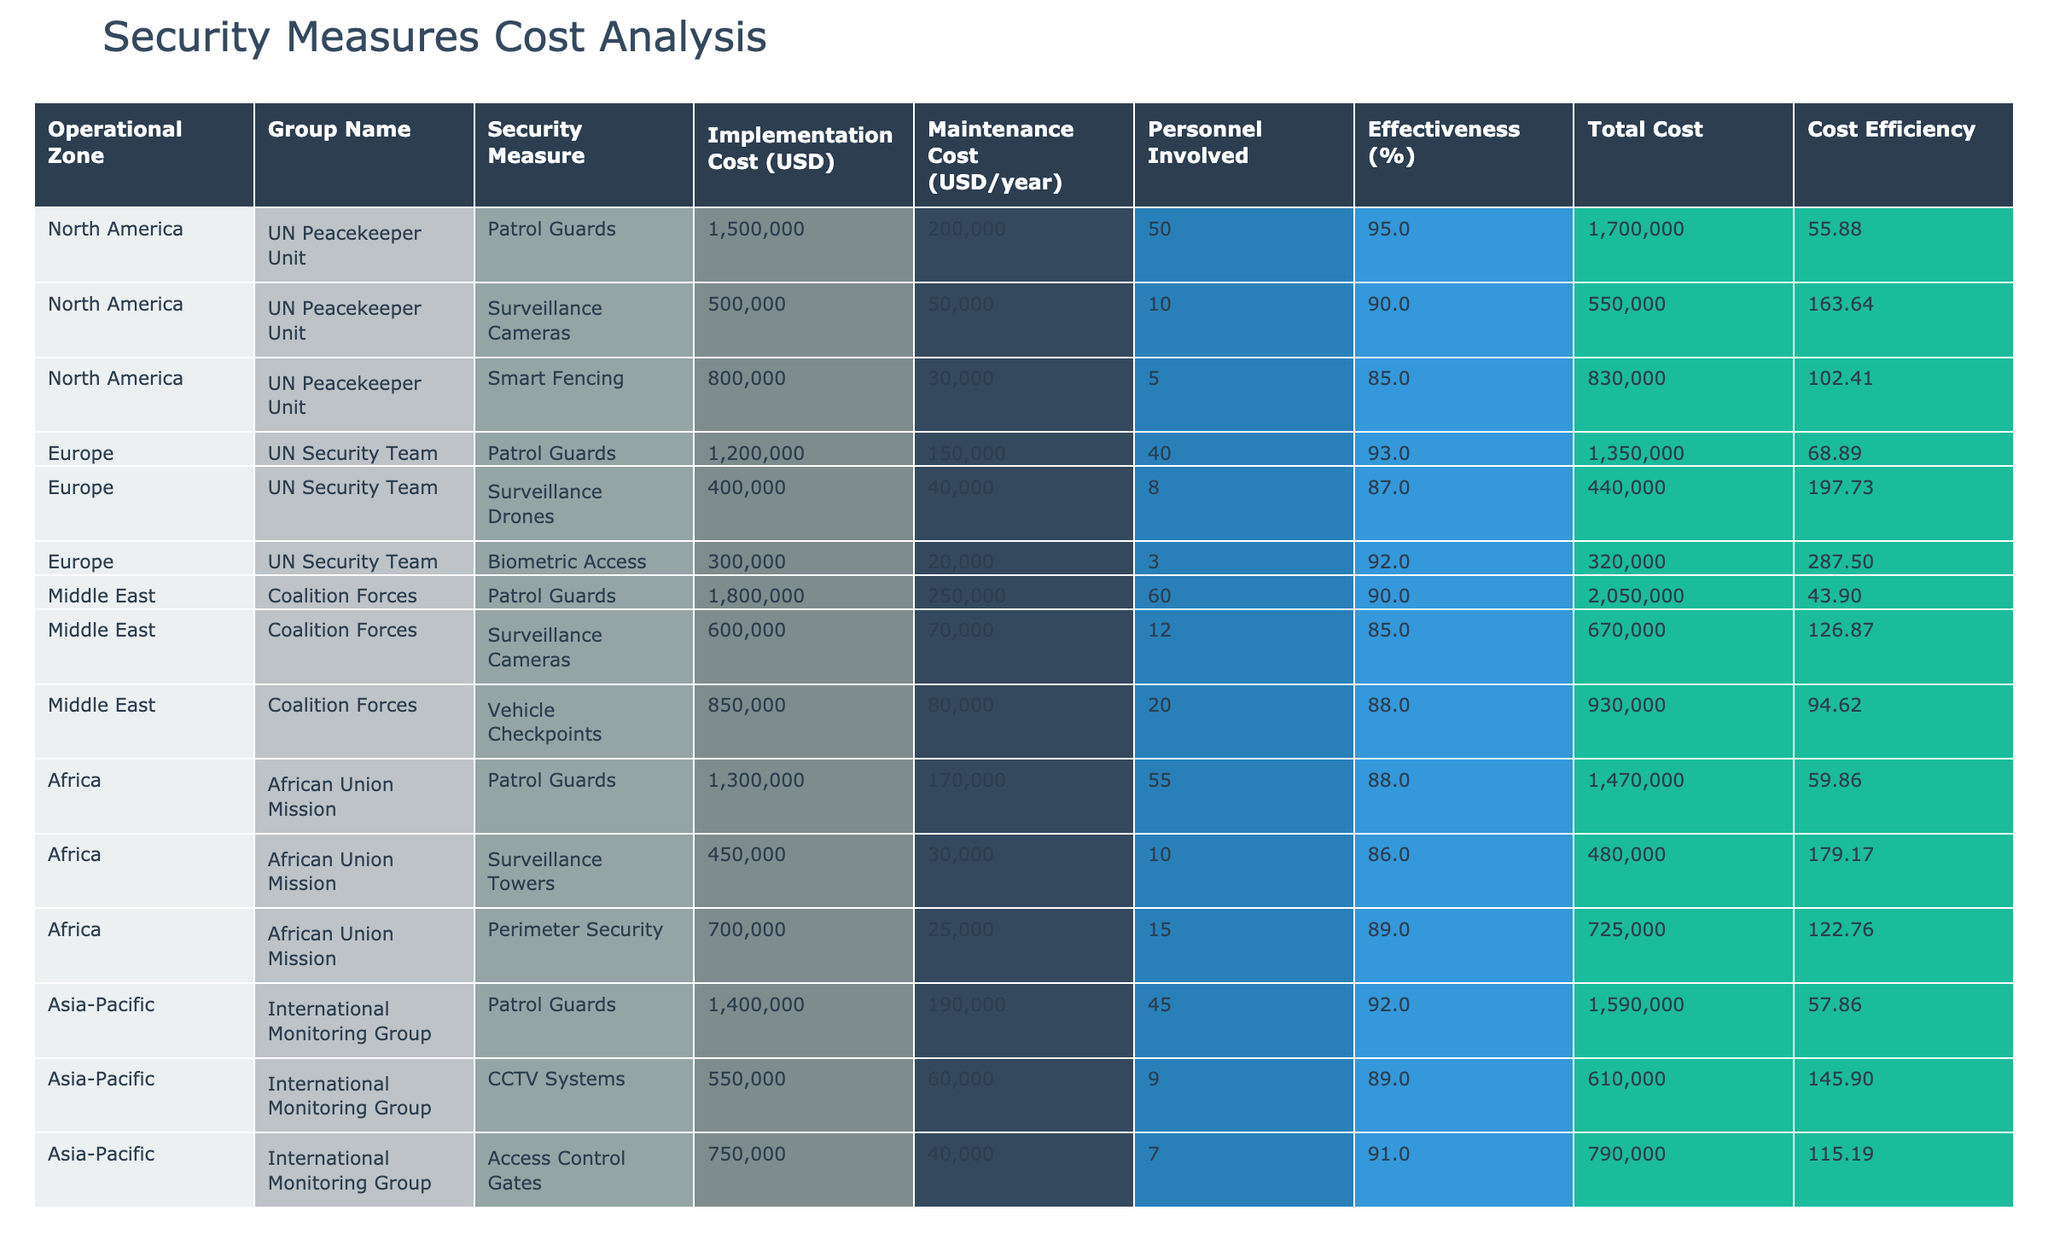What is the implementation cost of the surveillance cameras in the Middle East? From the table, the implementation cost of the surveillance cameras in the Middle East is listed under the corresponding row, showing a value of 600000 USD.
Answer: 600000 USD What is the total cost for security measures implemented by the African Union Mission? The total cost for the African Union Mission consists of the sum of the implementation cost and the annual maintenance cost for each measure. Calculating: (1300000 + 170000) + (450000 + 30000) + (700000 + 25000) = 1300000 + 170000 + 480000 + 30000 + 700000 + 25000 = 2230000 USD.
Answer: 2230000 USD Which security measure has the highest personnel involved and how many? The security measure with the highest personnel involved is the patrol guards in the Middle East, with a total of 60 personnel as seen in the corresponding row.
Answer: 60 Is the effectiveness of the surveillance drones in Europe greater than that of the smart fencing in North America? The effectiveness percentage of surveillance drones in Europe is 87%, while the smart fencing in North America is 85%. Since 87% is greater than 85%, the statement is true.
Answer: Yes What is the average effectiveness of security measures across all operational zones? To find the average effectiveness, sum the effectiveness percentages: 95 + 90 + 85 + 93 + 87 + 92 + 90 + 88 + 88 + 86 + 89 + 92 + 89 + 91 = 1203. There are 14 measures, so the average is 1203 / 14 ≈ 85.93%.
Answer: 85.93% Which operational zone has the lowest total maintenance cost, and what is the amount? By examining the maintenance costs, the lowest is from the African Union Mission with a total of 170000 USD yearly maintenance cost.
Answer: 170000 USD What is the difference in implementation costs between the patrol guards in North America and the patrol guards in the Middle East? The implementation cost for patrol guards in North America is 1500000 USD, while in the Middle East it is 1800000 USD. The difference is 1800000 - 1500000 = 300000 USD.
Answer: 300000 USD Which security measure has the lowest effectiveness percentage, and what is it? By reviewing the effectiveness percentages, the smart fencing (North America) has the lowest effectiveness at 85%.
Answer: 85% Is the total cost of security measures in the Asia-Pacific zone greater than that in Africa? First, calculate the total costs: Asia-Pacific: (1400000 + 190000) + (550000 + 60000) + (750000 + 40000) = 1400000 + 190000 + 550000 + 60000 + 750000 + 40000 = 2320000 USD; Africa: (1300000 + 170000) + (450000 + 30000) + (700000 + 25000) = 2230000 USD. Since 2320000 > 2230000, the statement is true.
Answer: Yes 